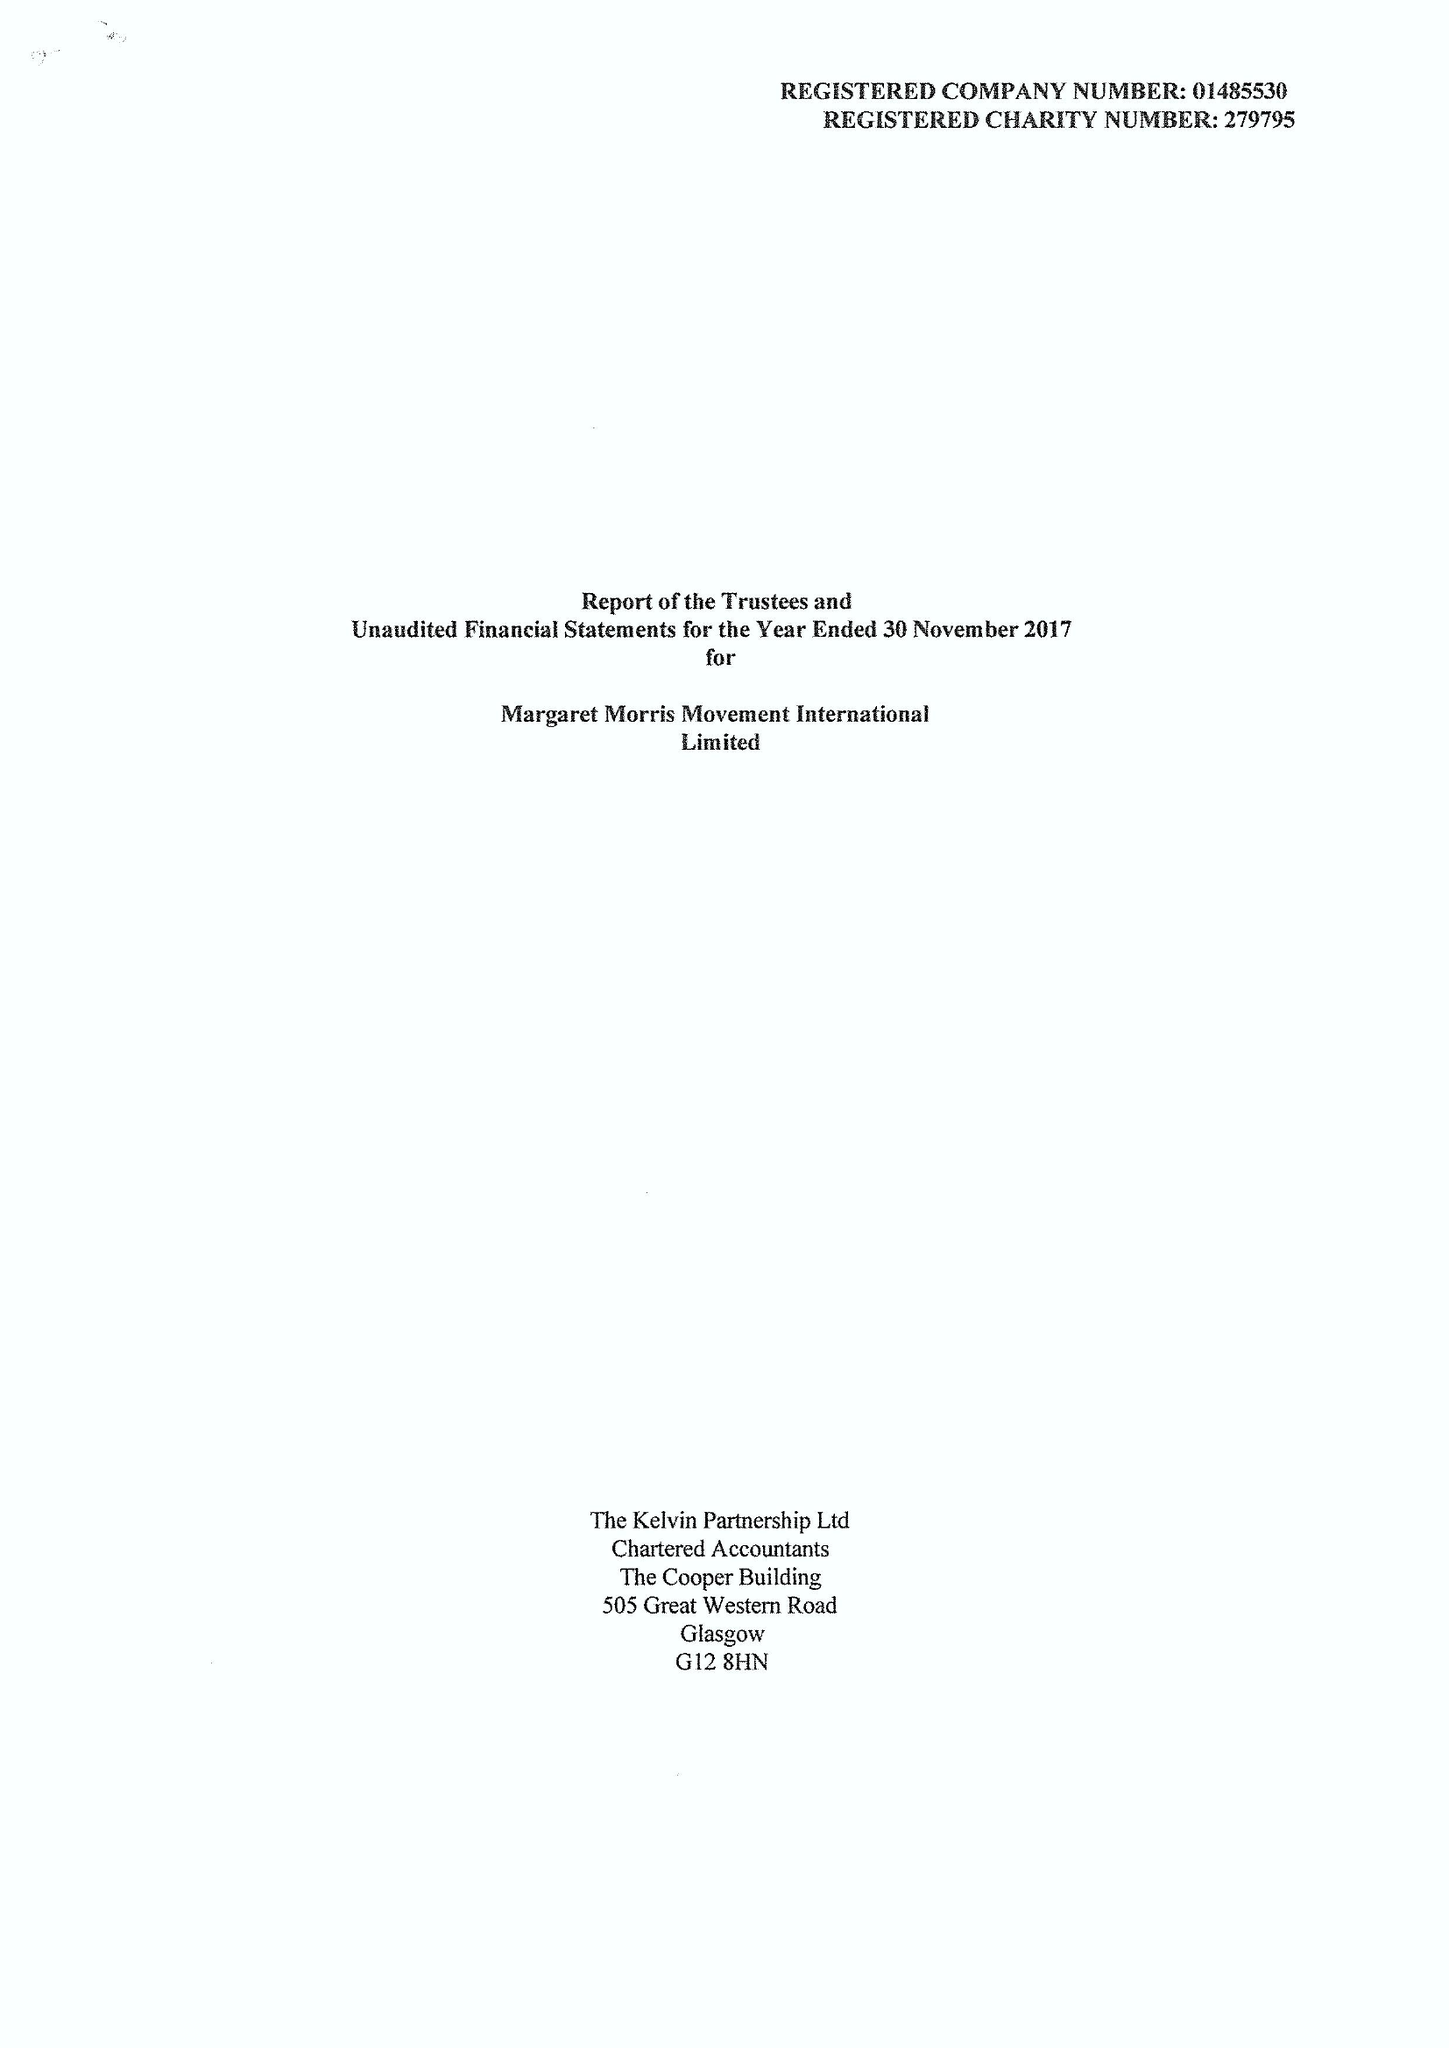What is the value for the address__post_town?
Answer the question using a single word or phrase. TELFORD 